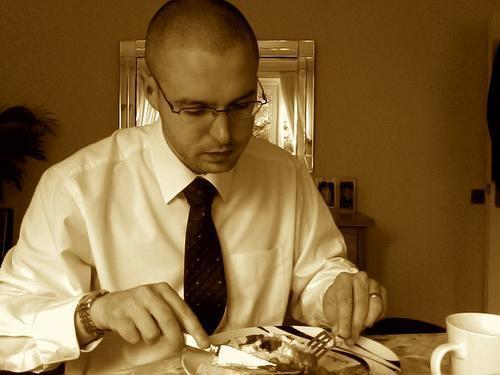How many people are in the room?
Give a very brief answer. 1. How many potted plants are there?
Give a very brief answer. 1. How many yellow bikes are there?
Give a very brief answer. 0. 